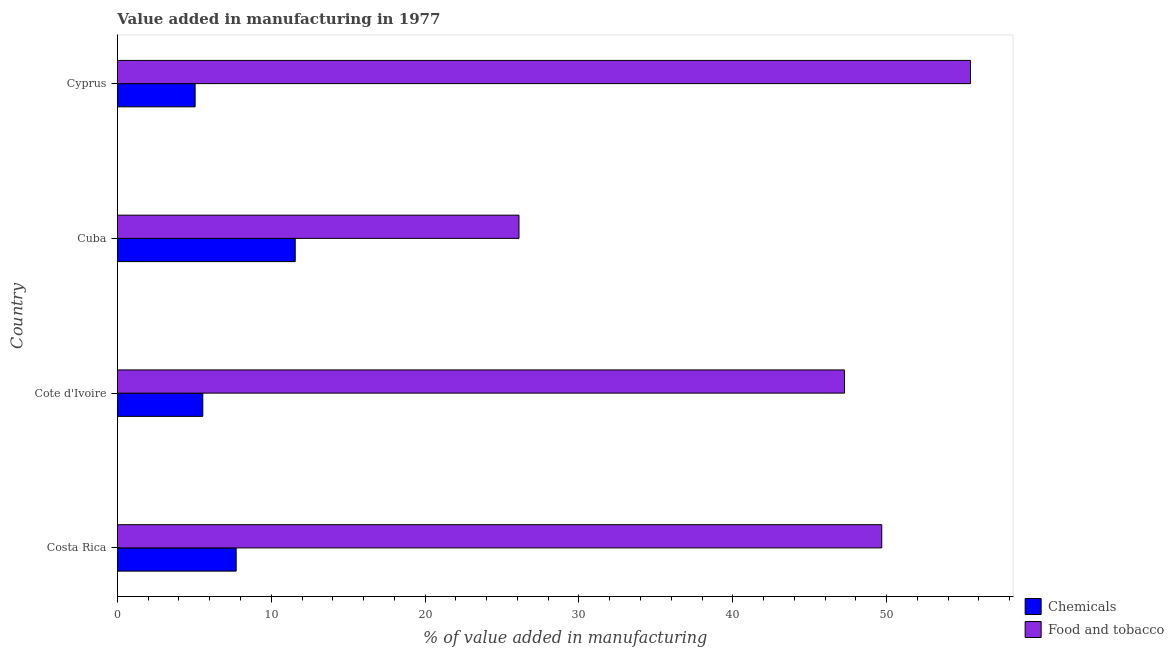How many groups of bars are there?
Your answer should be compact. 4. Are the number of bars per tick equal to the number of legend labels?
Give a very brief answer. Yes. How many bars are there on the 1st tick from the top?
Offer a terse response. 2. How many bars are there on the 1st tick from the bottom?
Give a very brief answer. 2. What is the label of the 2nd group of bars from the top?
Provide a succinct answer. Cuba. What is the value added by manufacturing food and tobacco in Cuba?
Provide a succinct answer. 26.1. Across all countries, what is the maximum value added by manufacturing food and tobacco?
Your answer should be very brief. 55.45. Across all countries, what is the minimum value added by manufacturing food and tobacco?
Offer a terse response. 26.1. In which country was the value added by  manufacturing chemicals maximum?
Offer a very short reply. Cuba. In which country was the value added by  manufacturing chemicals minimum?
Your answer should be compact. Cyprus. What is the total value added by  manufacturing chemicals in the graph?
Your answer should be compact. 29.88. What is the difference between the value added by manufacturing food and tobacco in Costa Rica and that in Cote d'Ivoire?
Provide a short and direct response. 2.42. What is the difference between the value added by  manufacturing chemicals in Cote d'Ivoire and the value added by manufacturing food and tobacco in Cyprus?
Provide a short and direct response. -49.9. What is the average value added by  manufacturing chemicals per country?
Your answer should be compact. 7.47. What is the difference between the value added by manufacturing food and tobacco and value added by  manufacturing chemicals in Costa Rica?
Keep it short and to the point. 41.96. What is the ratio of the value added by  manufacturing chemicals in Cote d'Ivoire to that in Cuba?
Make the answer very short. 0.48. What is the difference between the highest and the second highest value added by  manufacturing chemicals?
Your answer should be compact. 3.84. What is the difference between the highest and the lowest value added by  manufacturing chemicals?
Your response must be concise. 6.51. Is the sum of the value added by manufacturing food and tobacco in Costa Rica and Cote d'Ivoire greater than the maximum value added by  manufacturing chemicals across all countries?
Give a very brief answer. Yes. What does the 1st bar from the top in Cuba represents?
Make the answer very short. Food and tobacco. What does the 1st bar from the bottom in Cote d'Ivoire represents?
Ensure brevity in your answer.  Chemicals. How many bars are there?
Give a very brief answer. 8. Are all the bars in the graph horizontal?
Give a very brief answer. Yes. What is the difference between two consecutive major ticks on the X-axis?
Provide a succinct answer. 10. Does the graph contain any zero values?
Your answer should be very brief. No. Where does the legend appear in the graph?
Your answer should be compact. Bottom right. How many legend labels are there?
Keep it short and to the point. 2. How are the legend labels stacked?
Make the answer very short. Vertical. What is the title of the graph?
Your answer should be very brief. Value added in manufacturing in 1977. What is the label or title of the X-axis?
Your answer should be compact. % of value added in manufacturing. What is the % of value added in manufacturing of Chemicals in Costa Rica?
Your response must be concise. 7.72. What is the % of value added in manufacturing of Food and tobacco in Costa Rica?
Provide a succinct answer. 49.68. What is the % of value added in manufacturing in Chemicals in Cote d'Ivoire?
Keep it short and to the point. 5.55. What is the % of value added in manufacturing in Food and tobacco in Cote d'Ivoire?
Make the answer very short. 47.26. What is the % of value added in manufacturing of Chemicals in Cuba?
Give a very brief answer. 11.56. What is the % of value added in manufacturing in Food and tobacco in Cuba?
Provide a succinct answer. 26.1. What is the % of value added in manufacturing in Chemicals in Cyprus?
Provide a short and direct response. 5.05. What is the % of value added in manufacturing of Food and tobacco in Cyprus?
Your answer should be very brief. 55.45. Across all countries, what is the maximum % of value added in manufacturing of Chemicals?
Your answer should be compact. 11.56. Across all countries, what is the maximum % of value added in manufacturing of Food and tobacco?
Ensure brevity in your answer.  55.45. Across all countries, what is the minimum % of value added in manufacturing in Chemicals?
Keep it short and to the point. 5.05. Across all countries, what is the minimum % of value added in manufacturing of Food and tobacco?
Make the answer very short. 26.1. What is the total % of value added in manufacturing in Chemicals in the graph?
Provide a short and direct response. 29.88. What is the total % of value added in manufacturing in Food and tobacco in the graph?
Your answer should be very brief. 178.49. What is the difference between the % of value added in manufacturing of Chemicals in Costa Rica and that in Cote d'Ivoire?
Make the answer very short. 2.17. What is the difference between the % of value added in manufacturing of Food and tobacco in Costa Rica and that in Cote d'Ivoire?
Give a very brief answer. 2.42. What is the difference between the % of value added in manufacturing in Chemicals in Costa Rica and that in Cuba?
Give a very brief answer. -3.84. What is the difference between the % of value added in manufacturing of Food and tobacco in Costa Rica and that in Cuba?
Your answer should be very brief. 23.58. What is the difference between the % of value added in manufacturing in Chemicals in Costa Rica and that in Cyprus?
Your answer should be very brief. 2.67. What is the difference between the % of value added in manufacturing in Food and tobacco in Costa Rica and that in Cyprus?
Your response must be concise. -5.77. What is the difference between the % of value added in manufacturing of Chemicals in Cote d'Ivoire and that in Cuba?
Provide a short and direct response. -6.01. What is the difference between the % of value added in manufacturing in Food and tobacco in Cote d'Ivoire and that in Cuba?
Keep it short and to the point. 21.16. What is the difference between the % of value added in manufacturing in Chemicals in Cote d'Ivoire and that in Cyprus?
Make the answer very short. 0.5. What is the difference between the % of value added in manufacturing of Food and tobacco in Cote d'Ivoire and that in Cyprus?
Offer a terse response. -8.19. What is the difference between the % of value added in manufacturing in Chemicals in Cuba and that in Cyprus?
Offer a terse response. 6.51. What is the difference between the % of value added in manufacturing of Food and tobacco in Cuba and that in Cyprus?
Provide a succinct answer. -29.35. What is the difference between the % of value added in manufacturing in Chemicals in Costa Rica and the % of value added in manufacturing in Food and tobacco in Cote d'Ivoire?
Provide a succinct answer. -39.54. What is the difference between the % of value added in manufacturing in Chemicals in Costa Rica and the % of value added in manufacturing in Food and tobacco in Cuba?
Your answer should be compact. -18.38. What is the difference between the % of value added in manufacturing of Chemicals in Costa Rica and the % of value added in manufacturing of Food and tobacco in Cyprus?
Make the answer very short. -47.73. What is the difference between the % of value added in manufacturing of Chemicals in Cote d'Ivoire and the % of value added in manufacturing of Food and tobacco in Cuba?
Your answer should be compact. -20.55. What is the difference between the % of value added in manufacturing of Chemicals in Cote d'Ivoire and the % of value added in manufacturing of Food and tobacco in Cyprus?
Offer a very short reply. -49.9. What is the difference between the % of value added in manufacturing of Chemicals in Cuba and the % of value added in manufacturing of Food and tobacco in Cyprus?
Give a very brief answer. -43.89. What is the average % of value added in manufacturing in Chemicals per country?
Ensure brevity in your answer.  7.47. What is the average % of value added in manufacturing in Food and tobacco per country?
Give a very brief answer. 44.62. What is the difference between the % of value added in manufacturing in Chemicals and % of value added in manufacturing in Food and tobacco in Costa Rica?
Make the answer very short. -41.96. What is the difference between the % of value added in manufacturing of Chemicals and % of value added in manufacturing of Food and tobacco in Cote d'Ivoire?
Offer a very short reply. -41.71. What is the difference between the % of value added in manufacturing in Chemicals and % of value added in manufacturing in Food and tobacco in Cuba?
Offer a terse response. -14.54. What is the difference between the % of value added in manufacturing in Chemicals and % of value added in manufacturing in Food and tobacco in Cyprus?
Keep it short and to the point. -50.4. What is the ratio of the % of value added in manufacturing of Chemicals in Costa Rica to that in Cote d'Ivoire?
Your response must be concise. 1.39. What is the ratio of the % of value added in manufacturing in Food and tobacco in Costa Rica to that in Cote d'Ivoire?
Your response must be concise. 1.05. What is the ratio of the % of value added in manufacturing in Chemicals in Costa Rica to that in Cuba?
Offer a very short reply. 0.67. What is the ratio of the % of value added in manufacturing in Food and tobacco in Costa Rica to that in Cuba?
Make the answer very short. 1.9. What is the ratio of the % of value added in manufacturing in Chemicals in Costa Rica to that in Cyprus?
Offer a very short reply. 1.53. What is the ratio of the % of value added in manufacturing in Food and tobacco in Costa Rica to that in Cyprus?
Provide a succinct answer. 0.9. What is the ratio of the % of value added in manufacturing of Chemicals in Cote d'Ivoire to that in Cuba?
Ensure brevity in your answer.  0.48. What is the ratio of the % of value added in manufacturing in Food and tobacco in Cote d'Ivoire to that in Cuba?
Offer a very short reply. 1.81. What is the ratio of the % of value added in manufacturing in Chemicals in Cote d'Ivoire to that in Cyprus?
Your response must be concise. 1.1. What is the ratio of the % of value added in manufacturing of Food and tobacco in Cote d'Ivoire to that in Cyprus?
Offer a very short reply. 0.85. What is the ratio of the % of value added in manufacturing of Chemicals in Cuba to that in Cyprus?
Ensure brevity in your answer.  2.29. What is the ratio of the % of value added in manufacturing in Food and tobacco in Cuba to that in Cyprus?
Offer a very short reply. 0.47. What is the difference between the highest and the second highest % of value added in manufacturing of Chemicals?
Offer a terse response. 3.84. What is the difference between the highest and the second highest % of value added in manufacturing in Food and tobacco?
Offer a terse response. 5.77. What is the difference between the highest and the lowest % of value added in manufacturing of Chemicals?
Ensure brevity in your answer.  6.51. What is the difference between the highest and the lowest % of value added in manufacturing of Food and tobacco?
Your answer should be very brief. 29.35. 